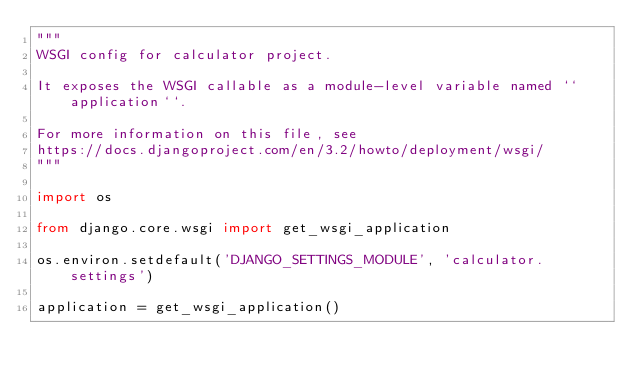Convert code to text. <code><loc_0><loc_0><loc_500><loc_500><_Python_>"""
WSGI config for calculator project.

It exposes the WSGI callable as a module-level variable named ``application``.

For more information on this file, see
https://docs.djangoproject.com/en/3.2/howto/deployment/wsgi/
"""

import os

from django.core.wsgi import get_wsgi_application

os.environ.setdefault('DJANGO_SETTINGS_MODULE', 'calculator.settings')

application = get_wsgi_application()
</code> 